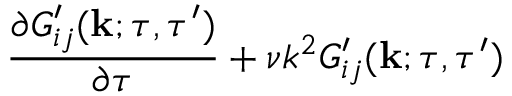Convert formula to latex. <formula><loc_0><loc_0><loc_500><loc_500>\begin{array} { r l r } { { \frac { \partial G _ { i j } ^ { \prime } ( { k } ; \tau , \tau ^ { \prime } ) } { \partial \tau } + \nu k ^ { 2 } G _ { i j } ^ { \prime } ( { k } ; \tau , \tau ^ { \prime } ) } } \end{array}</formula> 